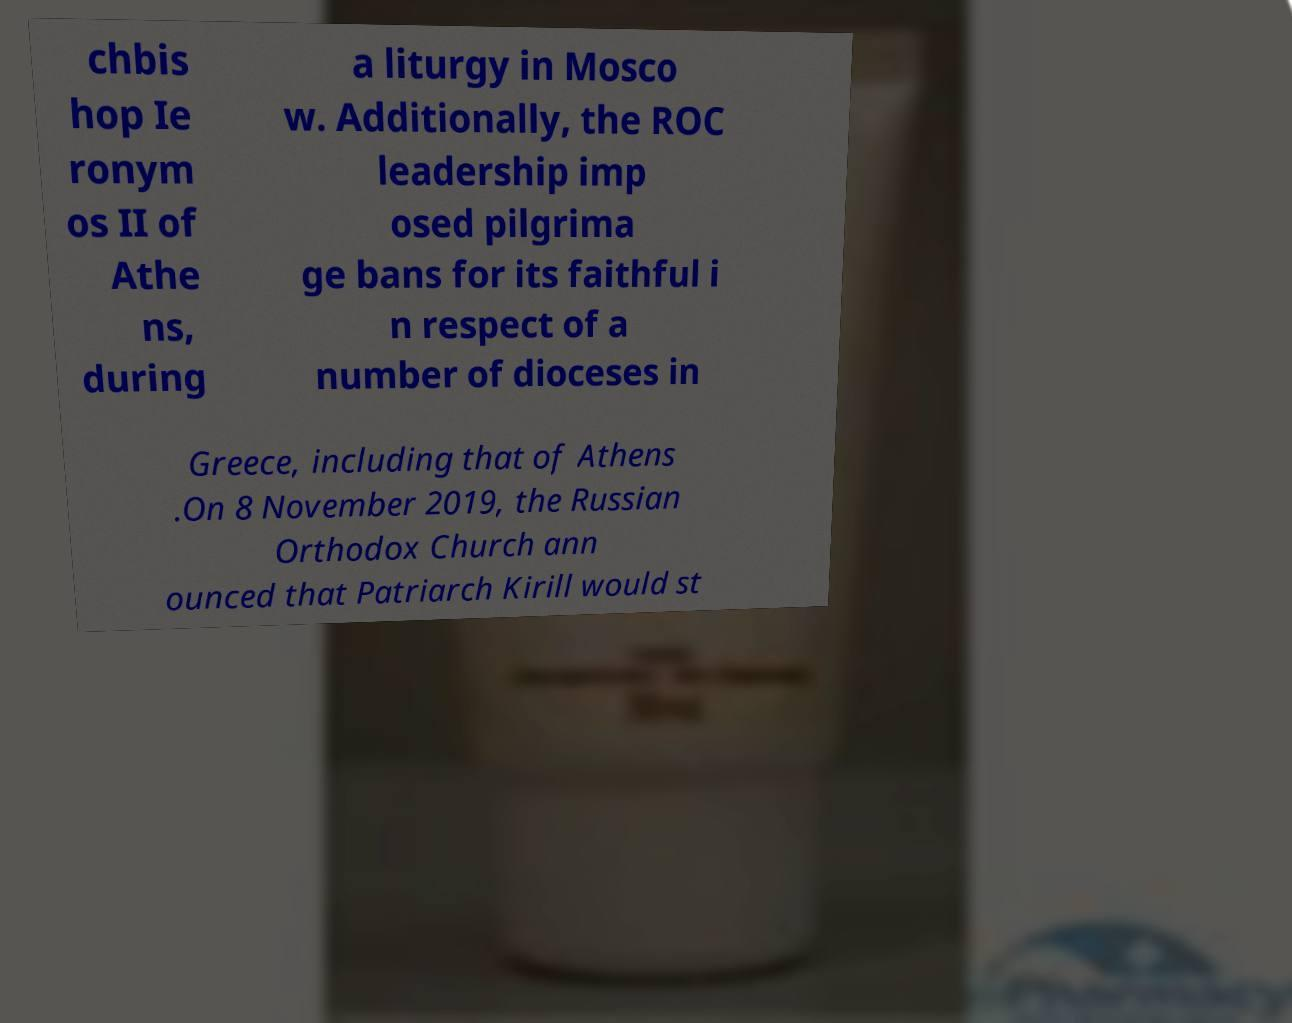Please identify and transcribe the text found in this image. chbis hop Ie ronym os II of Athe ns, during a liturgy in Mosco w. Additionally, the ROC leadership imp osed pilgrima ge bans for its faithful i n respect of a number of dioceses in Greece, including that of Athens .On 8 November 2019, the Russian Orthodox Church ann ounced that Patriarch Kirill would st 